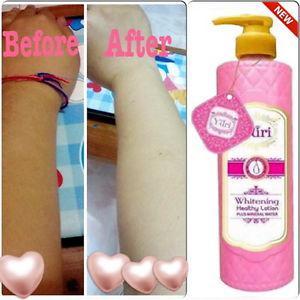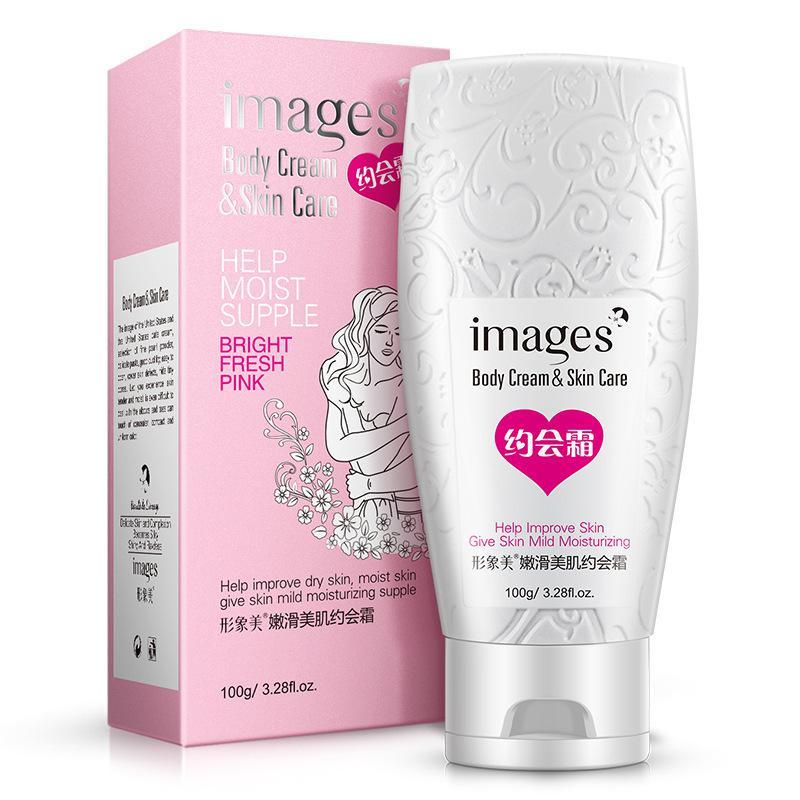The first image is the image on the left, the second image is the image on the right. Analyze the images presented: Is the assertion "The right image shows an angled row of at least three lotion products." valid? Answer yes or no. No. 